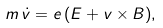<formula> <loc_0><loc_0><loc_500><loc_500>m \, \dot { v } = e \, ( { E } + { v } \times { B } ) ,</formula> 